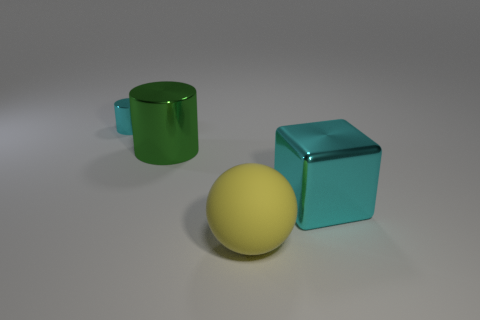Is the number of gray cylinders less than the number of yellow rubber balls? Yes, there are no gray cylinders in the image, making their number zero, which is indeed less than the single yellow rubber ball that is present. 